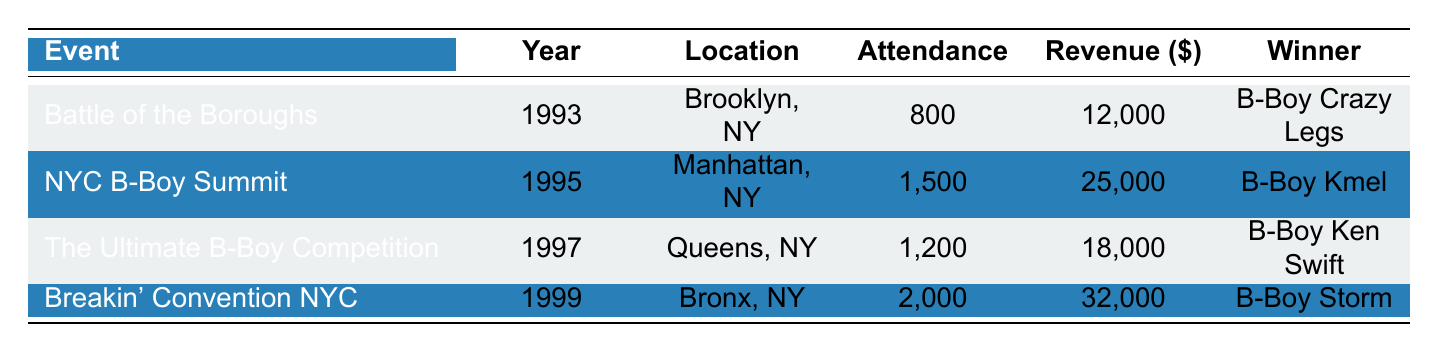What was the attendance for the NYC B-Boy Summit? The attendance for the NYC B-Boy Summit, which took place in 1995, is directly listed in the table. It shows an attendance of 1,500.
Answer: 1,500 Which event had the highest revenue? To find the highest revenue, I can compare the revenue values from each event listed in the table: 12,000 for Battle of the Boroughs, 25,000 for NYC B-Boy Summit, 18,000 for The Ultimate B-Boy Competition, and 32,000 for Breakin' Convention NYC. The highest value is 32,000 for Breakin' Convention NYC.
Answer: Breakin' Convention NYC Did the attendance increase or decrease from the Battle of the Boroughs to the Breakin' Convention NYC? Battle of the Boroughs had an attendance of 800 and Breakin' Convention NYC had an attendance of 2,000. Since 2,000 is greater than 800, it indicates an increase in attendance when transitioning from the first event to the last.
Answer: Increase What is the average revenue from all the events listed? To find the average revenue, I sum all the revenue figures: 12,000 + 25,000 + 18,000 + 32,000 = 87,000. Then, I divide this total by the number of events, which is 4. So, the average revenue is 87,000 / 4 = 21,750.
Answer: 21,750 Which location had the least number of attendees? By observing the attendance figures for each event: 800, 1,500, 1,200, and 2,000, I can see that the least number of attendees was at the Battle of the Boroughs, with 800 attendees.
Answer: Brooklyn, NY Is there a correlation between revenue and attendance among the events? To establish correlation, I look at the attendance and revenue of each event. In almost all instances, higher attendance corresponds to higher revenue. For example, the event with the highest attendance, Breakin' Convention NYC, also has the highest revenue, suggesting a positive correlation exists.
Answer: Yes How much more did Breakin' Convention NYC earn in revenue compared to The Ultimate B-Boy Competition? The revenue for Breakin' Convention NYC was 32,000 and for The Ultimate B-Boy Competition, it was 18,000. To find the difference, I subtract: 32,000 - 18,000 = 14,000.
Answer: 14,000 How many unique sponsors are listed in the events? I can identify each unique sponsor from all the events listed: Red Bull, Adidas, Puma, Sprayground, Nike, Monster Energy, Coca-Cola, and Hennessy. Counting these gives me a total of 8 unique sponsors.
Answer: 8 What year had the lowest attendance? By reviewing the attendance values for each event: 800 (1993), 1,500 (1995), 1,200 (1997), and 2,000 (1999), the lowest attendance occurred in 1993 during the Battle of the Boroughs, which had 800 attendees.
Answer: 1993 